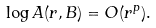<formula> <loc_0><loc_0><loc_500><loc_500>\log A ( r , B ) = O ( r ^ { p } ) .</formula> 